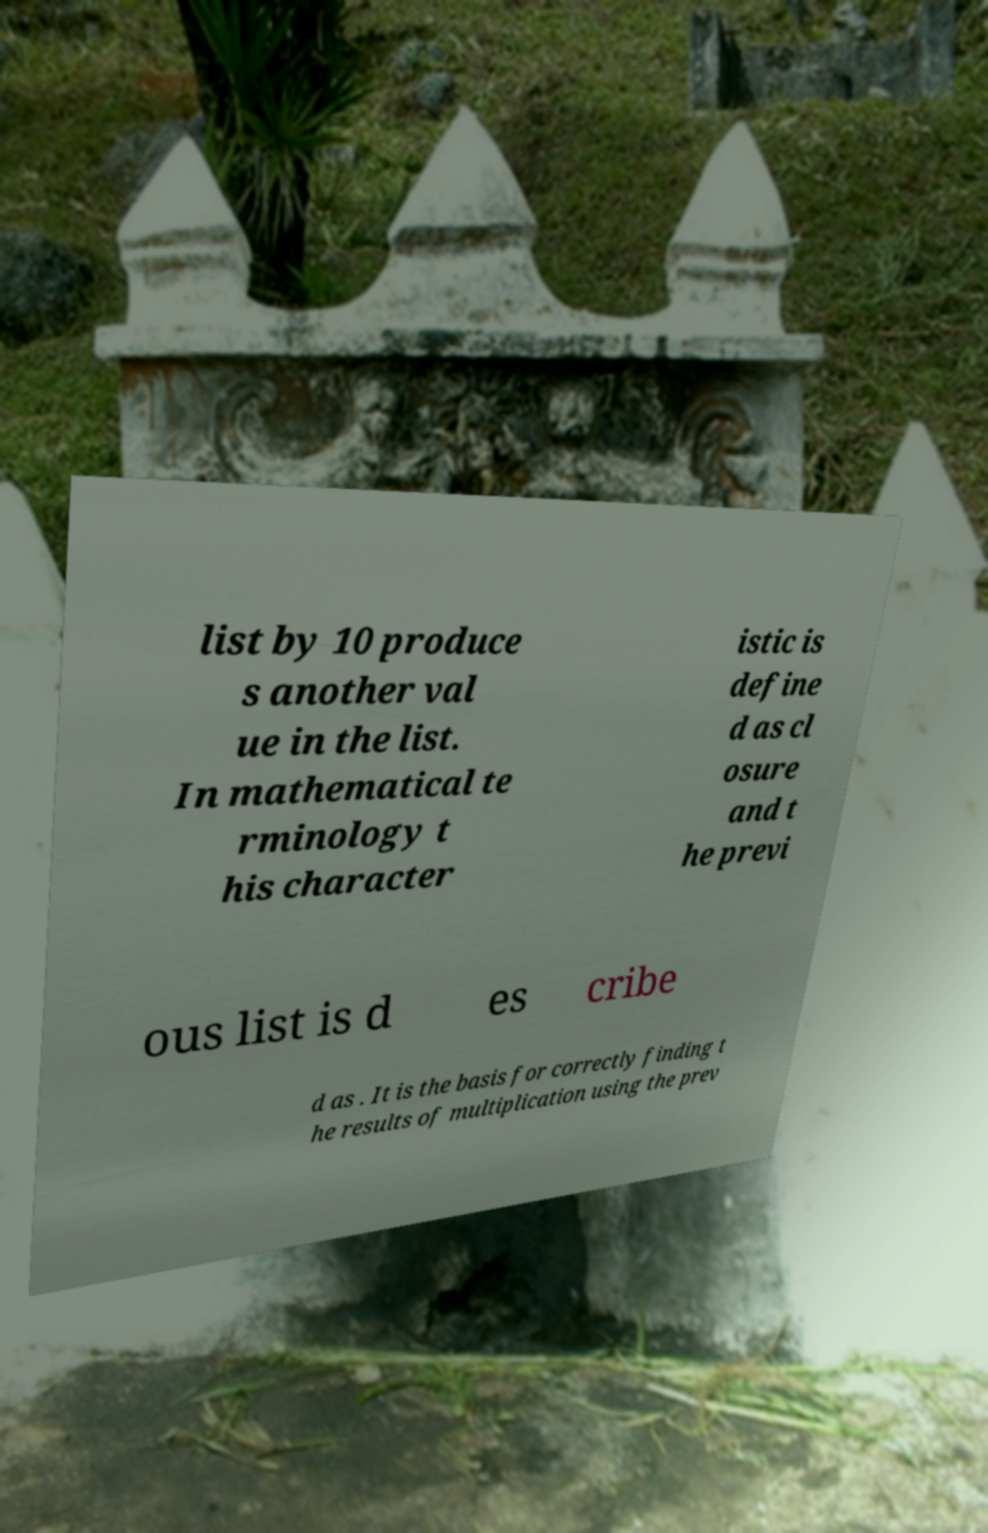Could you assist in decoding the text presented in this image and type it out clearly? list by 10 produce s another val ue in the list. In mathematical te rminology t his character istic is define d as cl osure and t he previ ous list is d es cribe d as . It is the basis for correctly finding t he results of multiplication using the prev 